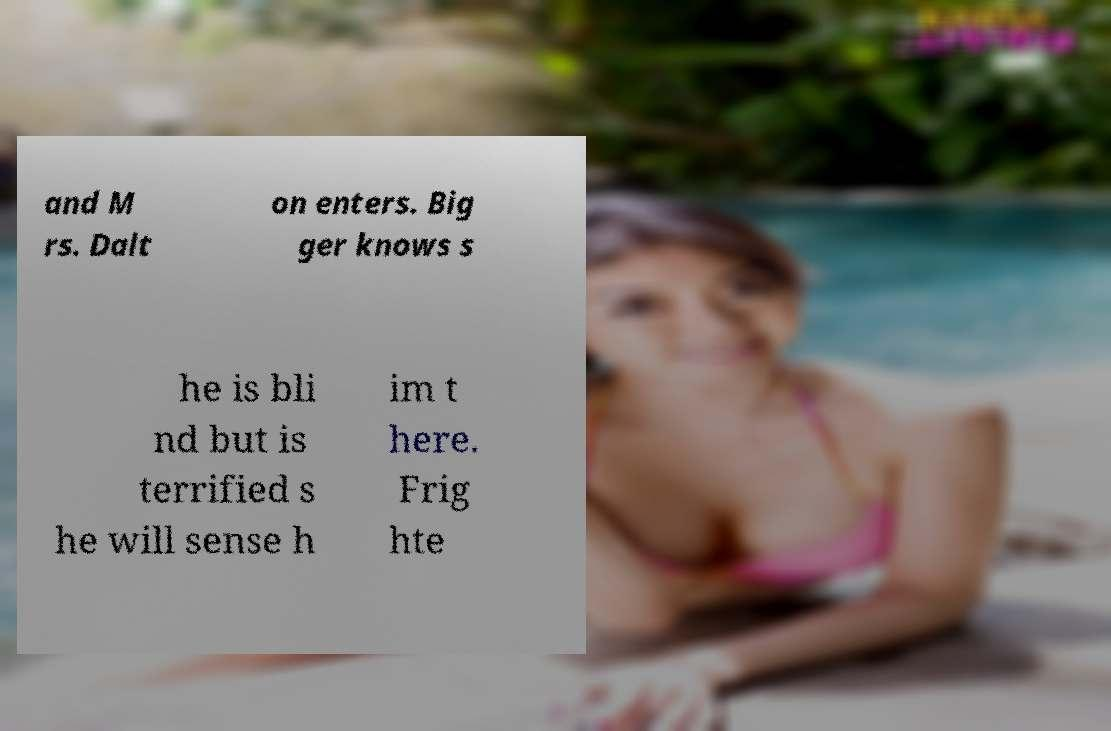For documentation purposes, I need the text within this image transcribed. Could you provide that? and M rs. Dalt on enters. Big ger knows s he is bli nd but is terrified s he will sense h im t here. Frig hte 